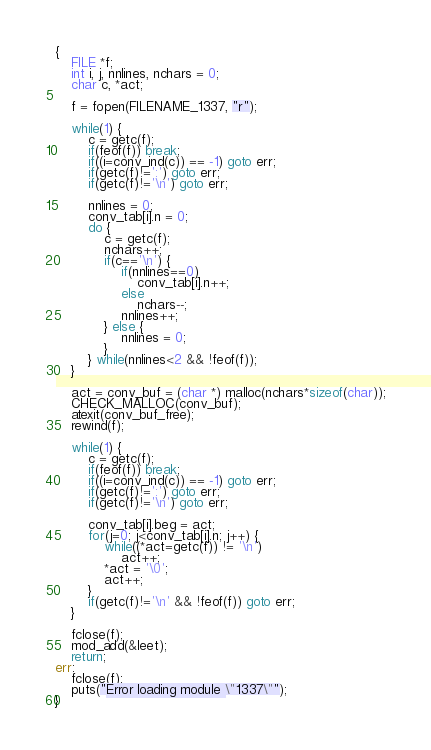<code> <loc_0><loc_0><loc_500><loc_500><_C_>{
	FILE *f;
	int i, j, nnlines, nchars = 0;
	char c, *act;

	f = fopen(FILENAME_1337, "r");

	while(1) {
		c = getc(f);
		if(feof(f)) break;
		if((i=conv_ind(c)) == -1) goto err;
		if(getc(f)!=':') goto err;
		if(getc(f)!='\n') goto err;

		nnlines = 0;
		conv_tab[i].n = 0;
		do {
			c = getc(f);
			nchars++;
			if(c=='\n') {
				if(nnlines==0)
					conv_tab[i].n++;
				else
					nchars--;
				nnlines++;
			} else {
				nnlines = 0;
			}
		} while(nnlines<2 && !feof(f));
	}

	act = conv_buf = (char *) malloc(nchars*sizeof(char));
	CHECK_MALLOC(conv_buf);
	atexit(conv_buf_free);
	rewind(f);

	while(1) {
		c = getc(f);
		if(feof(f)) break;
		if((i=conv_ind(c)) == -1) goto err; 
		if(getc(f)!=':') goto err;
		if(getc(f)!='\n') goto err;

		conv_tab[i].beg = act;
		for(j=0; j<conv_tab[i].n; j++) {
			while((*act=getc(f)) != '\n')
				act++;
			*act = '\0';
			act++;
		}
		if(getc(f)!='\n' && !feof(f)) goto err;
	}

	fclose(f);
	mod_add(&leet);
	return;
err:
	fclose(f);
	puts("Error loading module \"1337\"");
}
</code> 